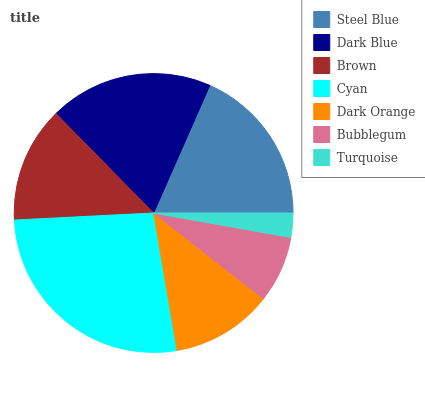Is Turquoise the minimum?
Answer yes or no. Yes. Is Cyan the maximum?
Answer yes or no. Yes. Is Dark Blue the minimum?
Answer yes or no. No. Is Dark Blue the maximum?
Answer yes or no. No. Is Dark Blue greater than Steel Blue?
Answer yes or no. Yes. Is Steel Blue less than Dark Blue?
Answer yes or no. Yes. Is Steel Blue greater than Dark Blue?
Answer yes or no. No. Is Dark Blue less than Steel Blue?
Answer yes or no. No. Is Brown the high median?
Answer yes or no. Yes. Is Brown the low median?
Answer yes or no. Yes. Is Turquoise the high median?
Answer yes or no. No. Is Cyan the low median?
Answer yes or no. No. 